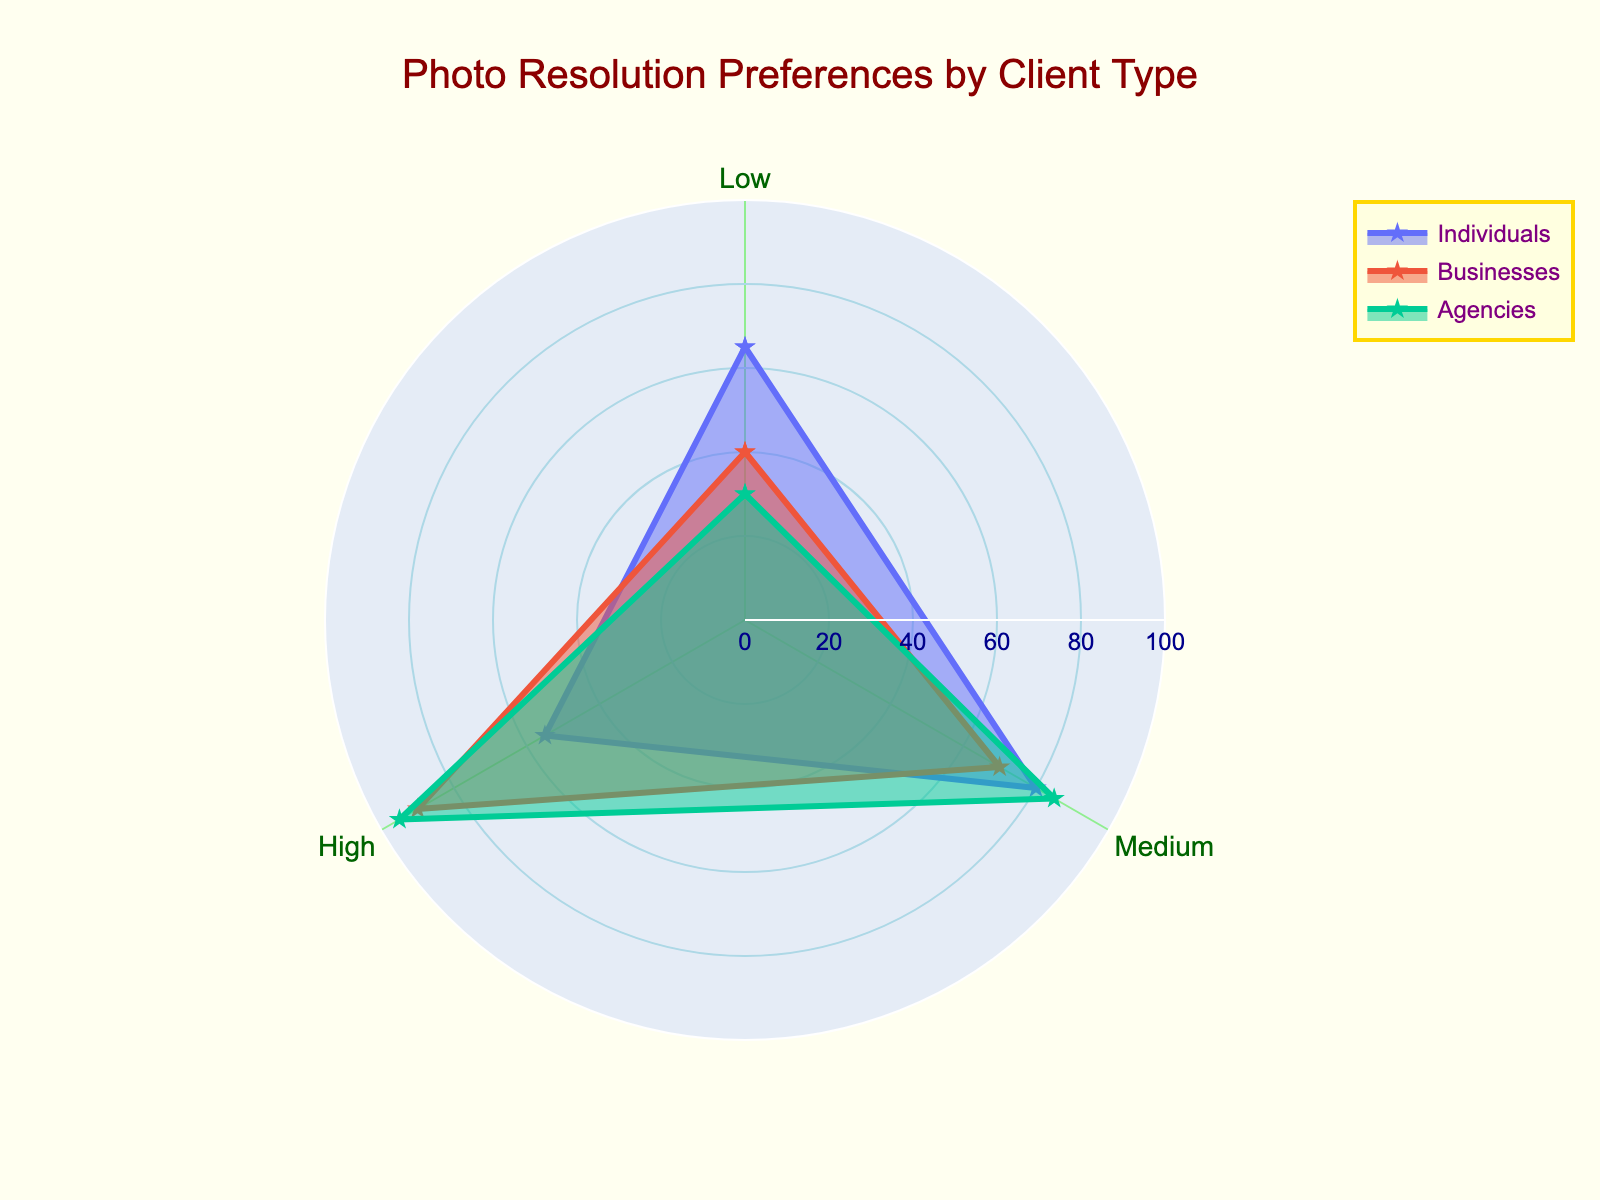What is the title of the chart? The title is directly displayed at the top of the chart with larger and bolder text. It provides an overview of what the chart represents.
Answer: Photo Resolution Preferences by Client Type Which client type has the highest preference for high resolution? To find the highest preference, look at the "High" resolution values for all client types. The one with the highest value will be at the top of the radar chart's spoke for high resolution.
Answer: Agencies What is the average preference score for medium resolution among all client types? Sum the preference scores for medium resolution for all client types and then divide by the number of client types: (80 (Individuals) + 70 (Businesses) + 85 (Agencies)) / 3 = 235 / 3 ≈ 78.33.
Answer: 78.33 Who prefers low resolution more, individuals or businesses? Compare the preference scores for low resolution between individuals and businesses. The value for individuals is 65, and for businesses, it is 40. Since 65 is greater than 40, individuals prefer low resolution more.
Answer: Individuals How much higher is agencies' preference score for high resolution compared to individuals? Subtract the high resolution score of individuals from that of agencies: 95 (Agencies) - 55 (Individuals) = 40.
Answer: 40 Which resolution has the highest preference score for businesses? Compare the preference scores for low, medium, and high resolutions for businesses. The values are 40 (Low), 70 (Medium), and 90 (High). The highest score is 90 for high resolution.
Answer: High Rank the client types in descending order of their preference for medium resolution. List the client types by their medium resolution scores in descending order: Agencies (85), Individuals (80), Businesses (70).
Answer: Agencies, Individuals, Businesses What is the overall range of preference scores visible on the radar chart? The radial axis visible range is from 0 to 100, as noted in the radial axis setup. This range encompasses all possible preference scores in the chart.
Answer: 0 to 100 